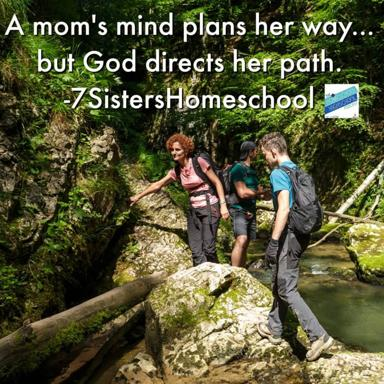What kind of setting are the people in the image walking through? The individuals in the image are navigating through a picturesque and possibly challenging stream within a dense, lush forest environment. This setting emphasizes a path not commonly taken, aligning metaphorically with the quote from the image about life’s unexpected journeys and the guidance one perceives along the way. 